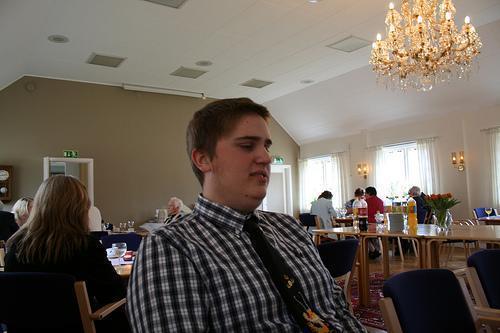How many other people are in the picture?
Give a very brief answer. 7. 